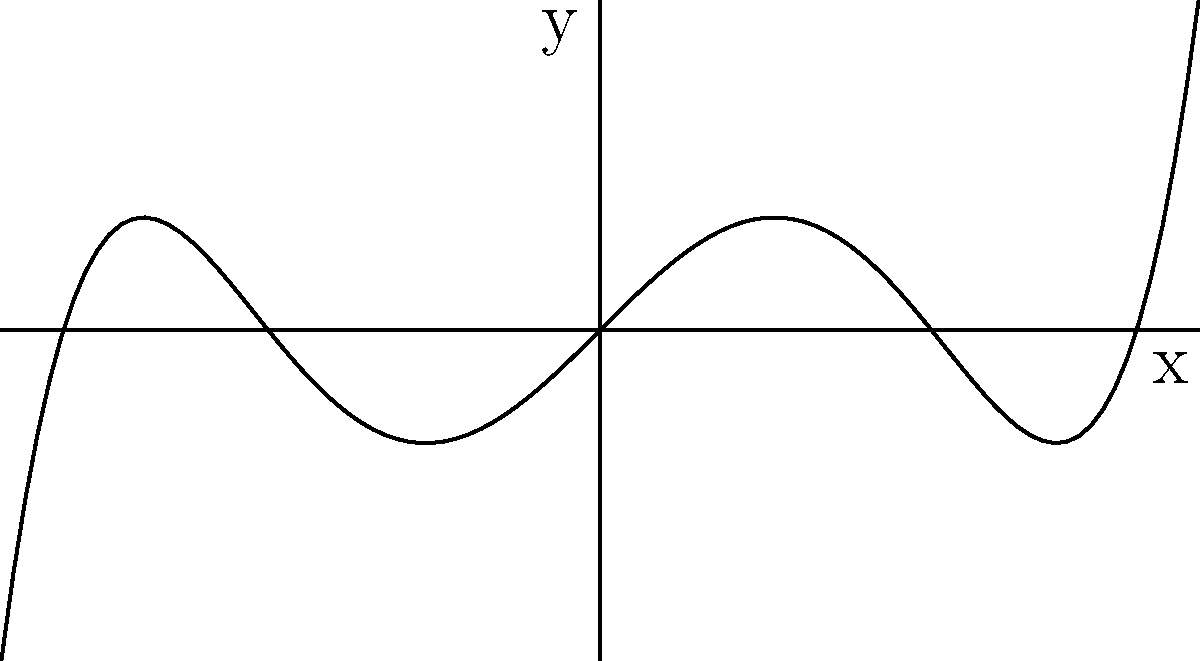Based on the end behavior of the polynomial function shown in the graph, determine the degree of the polynomial. How does this relate to the function's behavior as $x$ approaches positive and negative infinity? To determine the degree of a polynomial based on its graph's end behavior, we need to follow these steps:

1. Observe the behavior of the function as $x$ approaches positive and negative infinity.
2. In this graph, we can see that as $x$ approaches positive infinity, $y$ also approaches positive infinity.
3. As $x$ approaches negative infinity, $y$ approaches negative infinity.
4. This behavior indicates that the polynomial has an odd degree, as odd-degree polynomials have opposite behaviors at positive and negative infinity.
5. To determine the specific degree, we need to count the number of turns or changes in direction in the graph.
6. In this case, we can see two clear turning points.
7. The number of turning points is at most one less than the degree of the polynomial.
8. Therefore, the degree must be at least 3.
9. However, given the rapid increase in $y$ values at the ends of the graph, the degree is likely higher than 3.
10. The smallest odd degree that satisfies these conditions is 5.

Thus, the polynomial shown in the graph is most likely of degree 5.
Answer: Degree 5 